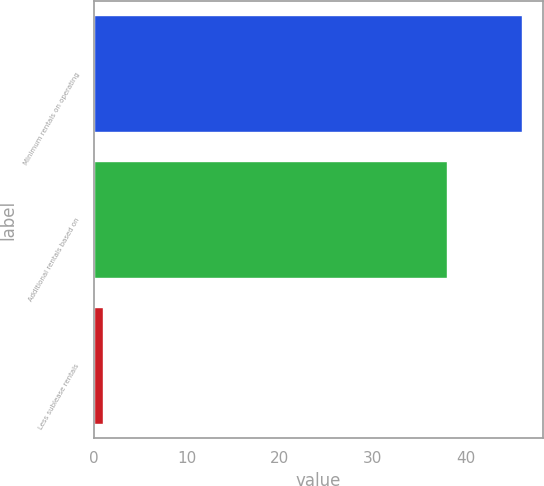Convert chart. <chart><loc_0><loc_0><loc_500><loc_500><bar_chart><fcel>Minimum rentals on operating<fcel>Additional rentals based on<fcel>Less sublease rentals<nl><fcel>46<fcel>38<fcel>1<nl></chart> 